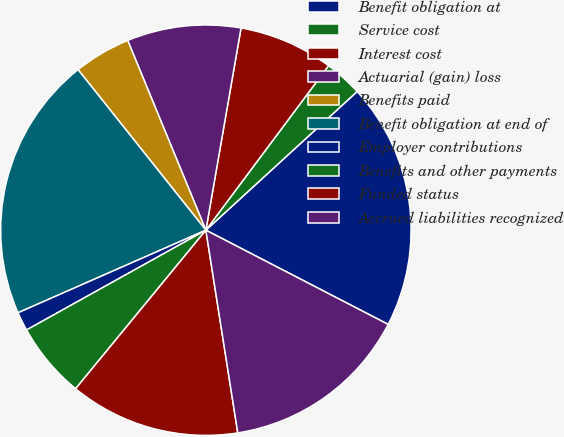<chart> <loc_0><loc_0><loc_500><loc_500><pie_chart><fcel>Benefit obligation at<fcel>Service cost<fcel>Interest cost<fcel>Actuarial (gain) loss<fcel>Benefits paid<fcel>Benefit obligation at end of<fcel>Employer contributions<fcel>Benefits and other payments<fcel>Funded status<fcel>Accrued liabilities recognized<nl><fcel>19.4%<fcel>2.99%<fcel>7.46%<fcel>8.96%<fcel>4.48%<fcel>20.89%<fcel>1.49%<fcel>5.97%<fcel>13.43%<fcel>14.92%<nl></chart> 